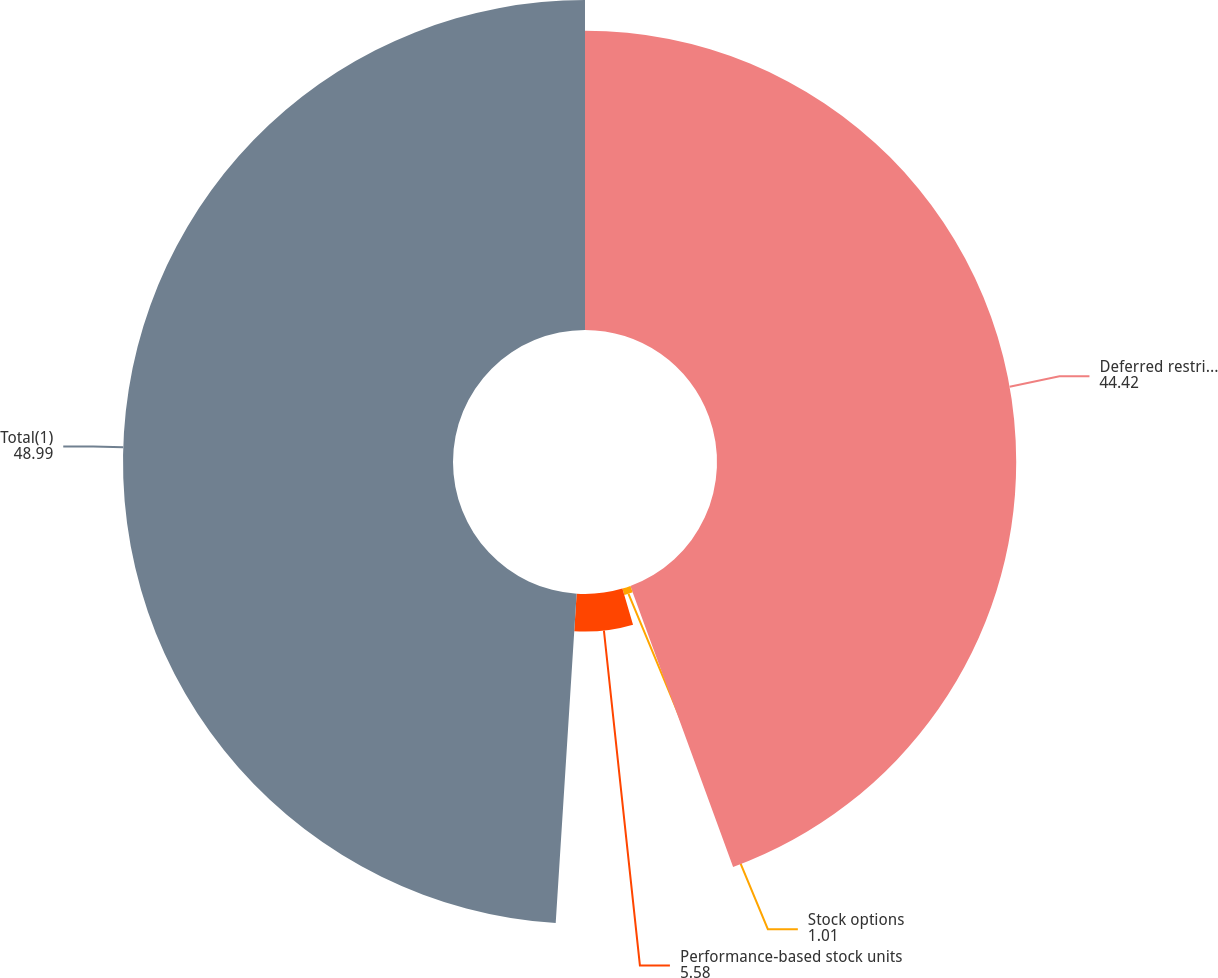Convert chart to OTSL. <chart><loc_0><loc_0><loc_500><loc_500><pie_chart><fcel>Deferred restricted stock<fcel>Stock options<fcel>Performance-based stock units<fcel>Total(1)<nl><fcel>44.42%<fcel>1.01%<fcel>5.58%<fcel>48.99%<nl></chart> 